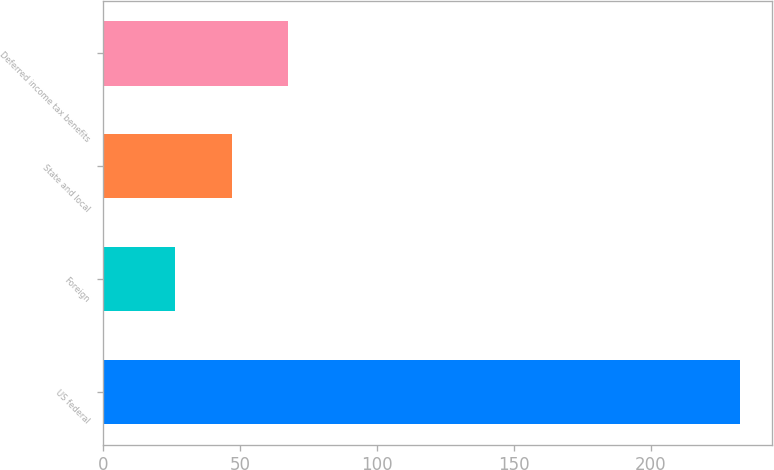Convert chart. <chart><loc_0><loc_0><loc_500><loc_500><bar_chart><fcel>US federal<fcel>Foreign<fcel>State and local<fcel>Deferred income tax benefits<nl><fcel>232.5<fcel>26.5<fcel>47.1<fcel>67.7<nl></chart> 